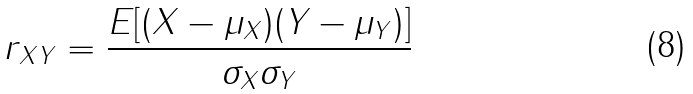Convert formula to latex. <formula><loc_0><loc_0><loc_500><loc_500>r _ { X Y } = \frac { E [ ( X - \mu _ { X } ) ( Y - \mu _ { Y } ) ] } { \sigma _ { X } \sigma _ { Y } }</formula> 